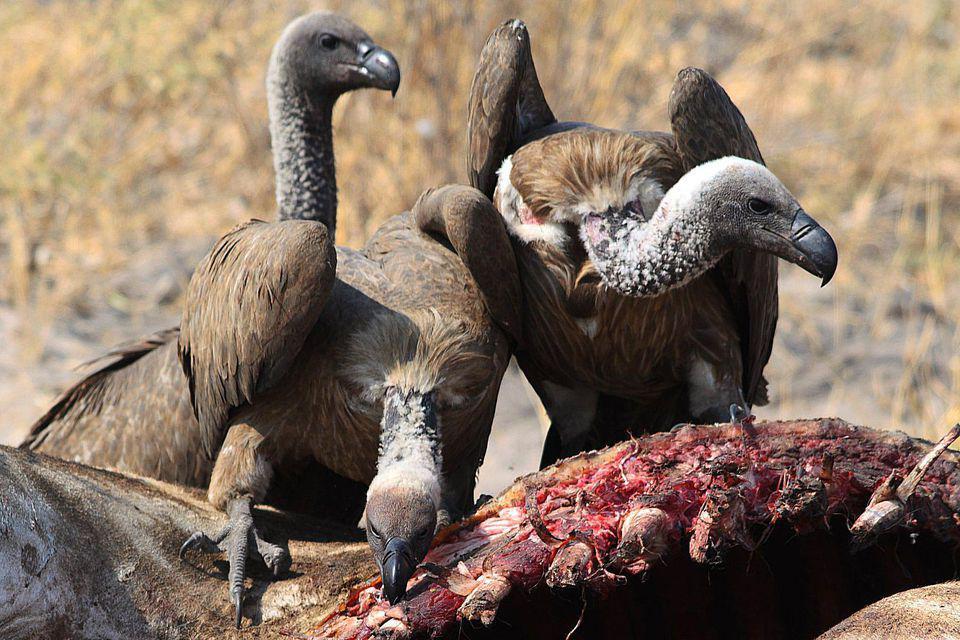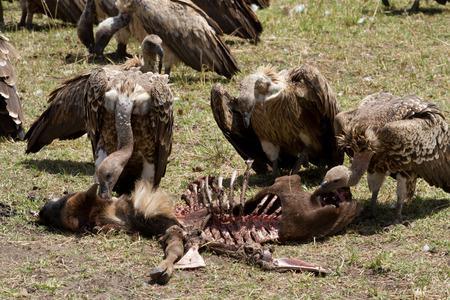The first image is the image on the left, the second image is the image on the right. Examine the images to the left and right. Is the description "There is a total of 1 fox with 1 or more buzzards." accurate? Answer yes or no. No. 